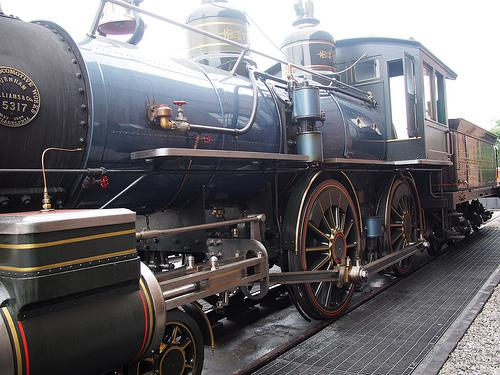Question: how is the locomotive viewed?
Choices:
A. It is a museum piece.
B. At the train museum.
C. From a safe distance.
D. At the railway museum.
Answer with the letter. Answer: A Question: what powers this engine?
Choices:
A. Water.
B. The sun.
C. Electricity.
D. Steam.
Answer with the letter. Answer: D Question: who drives the locomotive?
Choices:
A. The conductor.
B. A train engineer.
C. The engine driver.
D. A railway employee.
Answer with the letter. Answer: B Question: where is this scene?
Choices:
A. At MOSI.
B. A display at a park or museum.
C. At Disneyland.
D. At Busch Gardens.
Answer with the letter. Answer: B Question: why was it displayed?
Choices:
A. Historical preservation.
B. For future generations.
C. It is culturally significant.
D. It is ancient.
Answer with the letter. Answer: A Question: what moves the large wheels?
Choices:
A. Pistons.
B. The steam power.
C. The engine.
D. Inertia.
Answer with the letter. Answer: A 